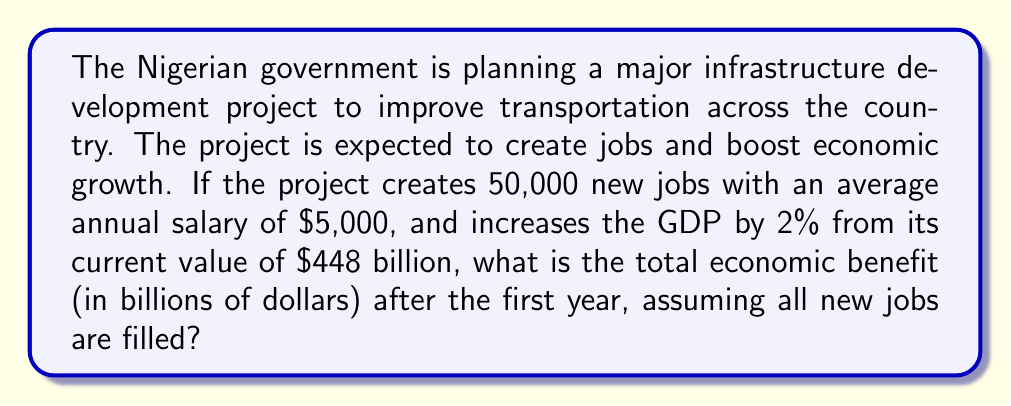Could you help me with this problem? Let's break this down step-by-step:

1) First, calculate the economic benefit from job creation:
   Number of new jobs = 50,000
   Average annual salary = $5,000
   Total salary benefit = $50,000 × $5,000 = $250,000,000 = $0.25 billion

2) Now, calculate the increase in GDP:
   Current GDP = $448 billion
   GDP increase = 2% = 0.02
   GDP benefit = $448 billion × 0.02 = $8.96 billion

3) Total economic benefit is the sum of job creation benefit and GDP increase:
   Total benefit = Salary benefit + GDP benefit
   $$ \text{Total benefit} = 0.25 + 8.96 = 9.21 \text{ billion dollars} $$

This infrastructure project would bring significant economic benefits to Nigeria, promoting unity and progress through improved transportation and economic growth.
Answer: $9.21 billion 